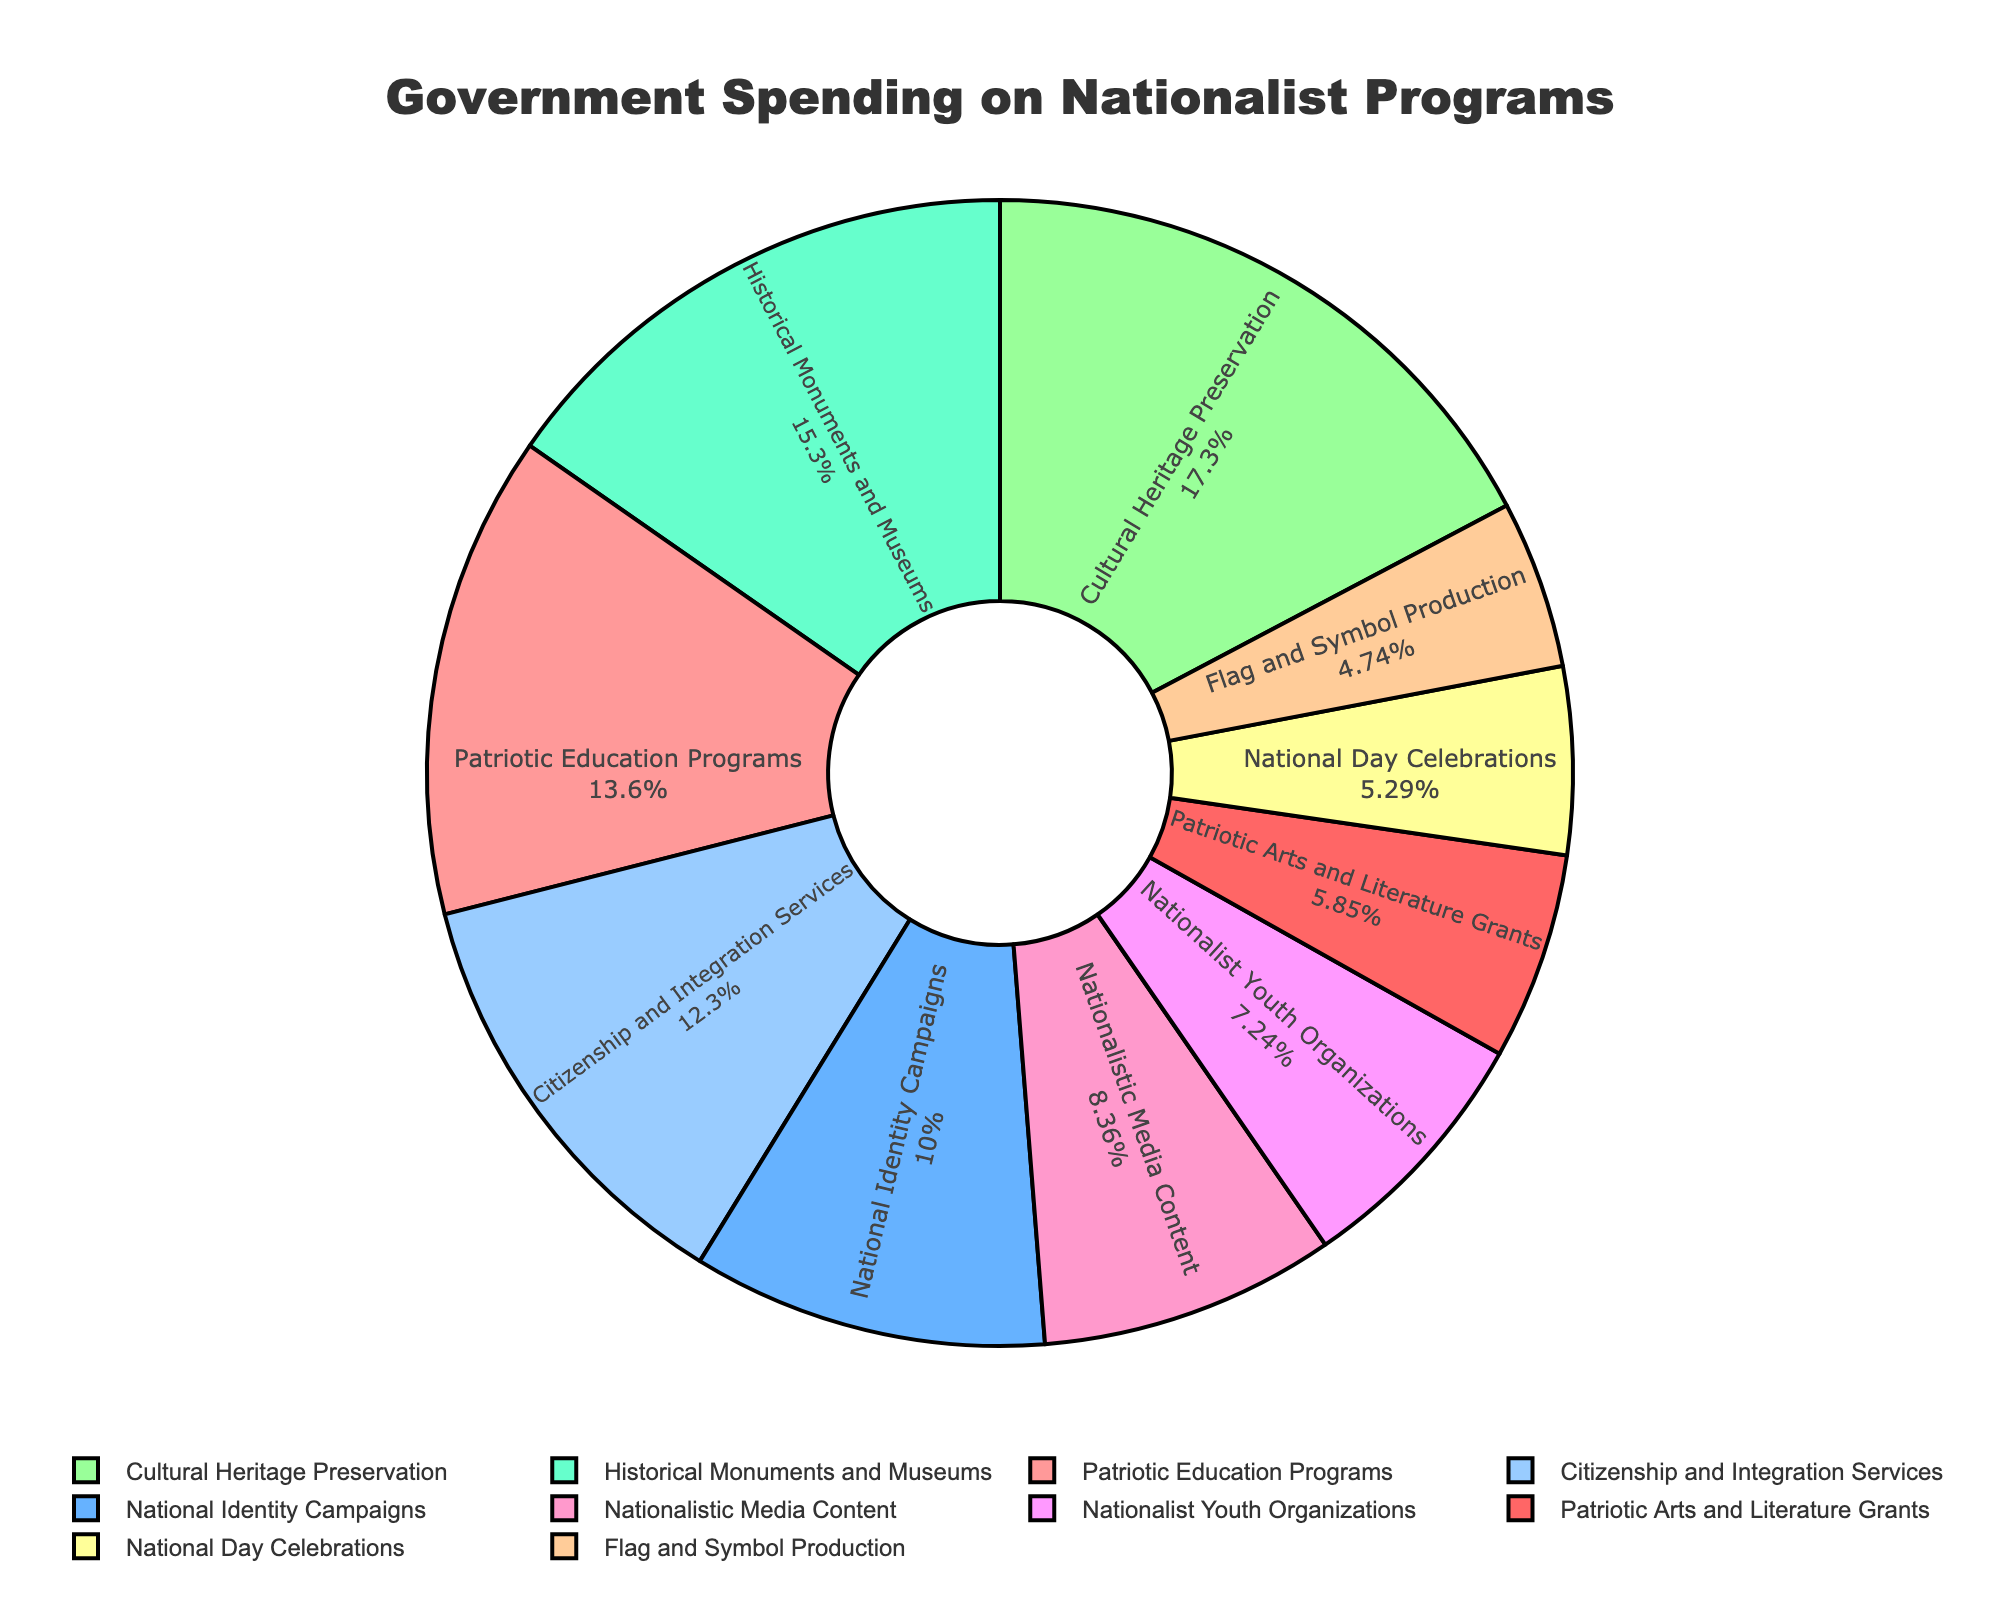Which category has the highest government spending? The chart shows several categories with their respective spending amounts. By visually scanning the sections, we identify that "Cultural Heritage Preservation" has the largest segment, indicating the highest spending.
Answer: Cultural Heritage Preservation Which category has the lowest spending? By visually inspecting the pie chart and identifying the smallest segment, we find that "Flag and Symbol Production" has the lowest spending.
Answer: Flag and Symbol Production How much more is spent on Historical Monuments and Museums compared to National Day Celebrations? Locate the two segments on the chart and note their spending amounts. Subtract the spending on National Day Celebrations (95 million) from the spending on Historical Monuments and Museums (275 million).
Answer: 180 million Which two categories combined account for the largest proportion of spending? Identify the two largest segments on the pie chart: "Cultural Heritage Preservation" (310 million) and "Historical Monuments and Museums" (275 million). Together, these form the largest combined proportion.
Answer: Cultural Heritage Preservation and Historical Monuments and Museums How much total is spent on Patriotic Education Programs, National Identity Campaigns, and Nationalist Youth Organizations? Sum the spending amounts for the three categories: 245 million (Patriotic Education Programs) + 180 million (National Identity Campaigns) + 130 million (Nationalist Youth Organizations).
Answer: 555 million What proportion of the total spending is dedicated to Patriot Education Programs and National Identity Campaigns together? Add the spending of these two categories: 245 million (Patriotic Education Programs) + 180 million (National Identity Campaigns). Then divide by the total spending, and multiply by 100 to find the percentage.
Answer: 24.25% Does Nationalistic Media Content receive more or less funding than Patriotic Arts and Literature Grants? Compare the segments representing these categories. Nationalistic Media Content receives 150 million, whereas Patriotic Arts and Literature Grants receive 105 million.
Answer: More Which category focused on education has the highest funding? Compare the funding amounts for "Patriotic Education Programs" (245 million) and "Citizenship and Integration Services" (220 million).
Answer: Patriotic Education Programs If the government decided to double the spending on Flag and Symbol Production, how would that compare to the spending on Nationalist Youth Organizations? Double the spending on Flag and Symbol Production (85 million * 2 = 170 million) and compare it to Nationalist Youth Organizations' spending (130 million).
Answer: More What is the average spending across all categories? Sum all the spending amounts and divide by the number of categories (10). Total sum = 1795 million, so the average = 1795 / 10.
Answer: 179.5 million 